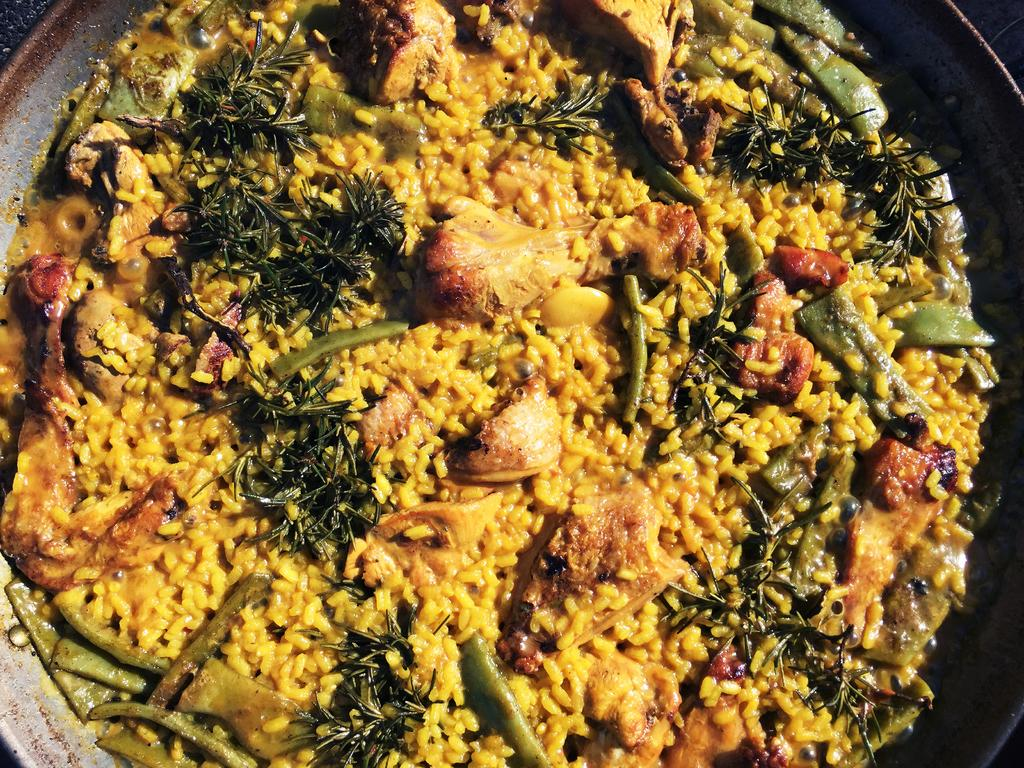What is present in the image? There is a bowl in the image. What is inside the bowl? There is a food item in the bowl. What type of vest is being worn by the food item in the image? There is no vest or any clothing present in the image, as it features a bowl with a food item. 